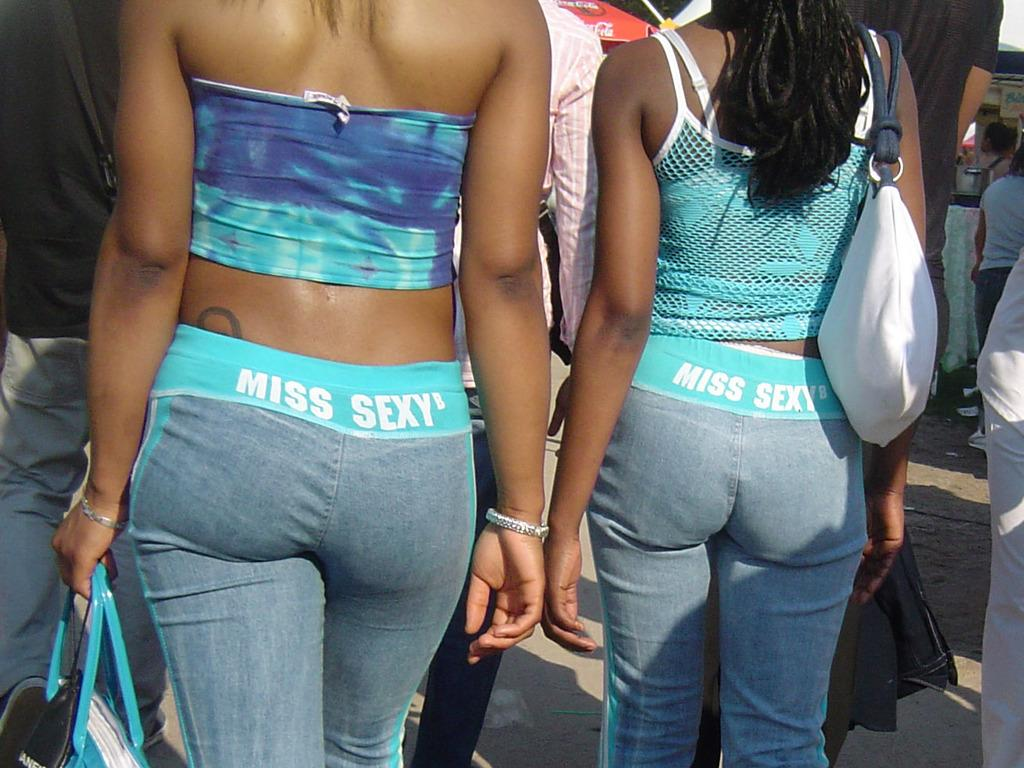How many women are in the image? There are two women standing in the image. What is written behind the women? The words "miss sexy" are written on something behind the women. Can you describe the people in front of the women? There are other persons in front of the women. What type of yam is being served to the crowd in the image? There is no yam or crowd present in the image. How many teeth can be seen in the mouth of the woman on the left? There is no mouth or teeth visible in the image. 